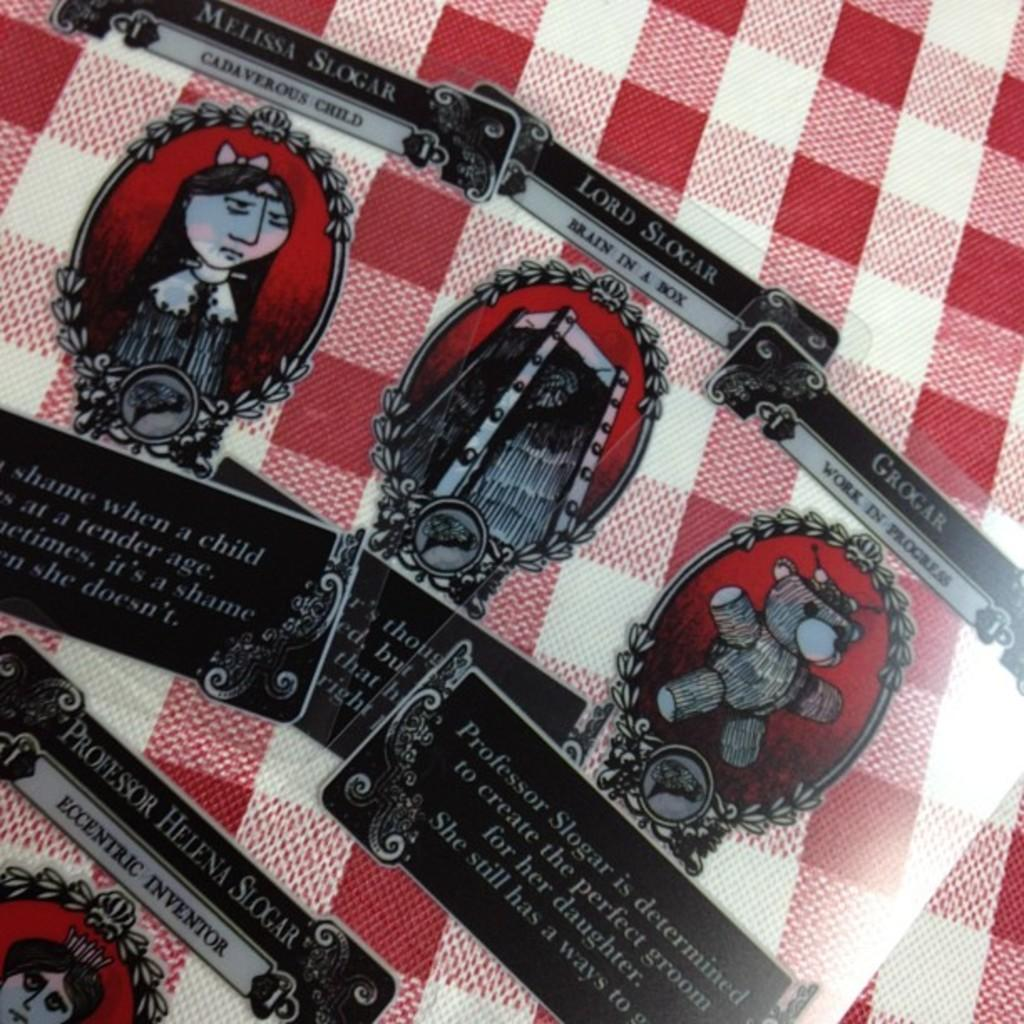What objects are present in the image? There are cards in the image. What can be observed about the cards? The cards have different pictures on them. On what surface are the cards placed? The cards are placed on a cloth surface. What type of jeans can be seen in the image? There are no jeans present in the image; it only features cards with different pictures on them placed on a cloth surface. 